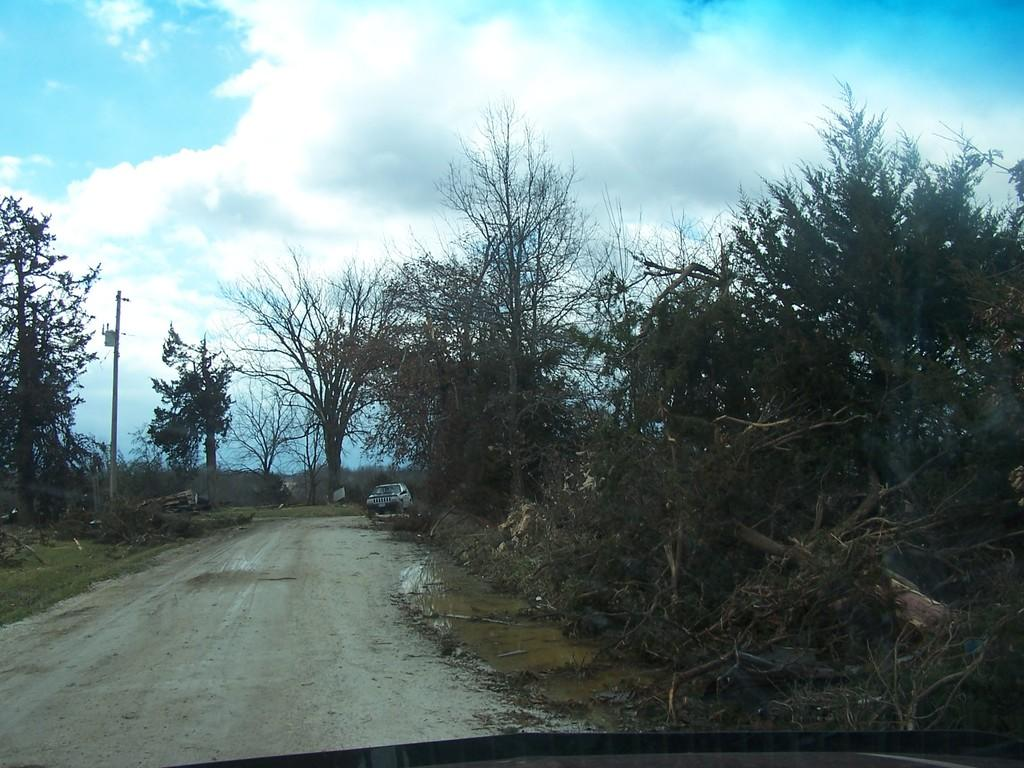What is the main subject in the image? There is a vehicle in the image. What type of natural elements can be seen in the image? There are trees and grass visible in the image. What man-made object is present in the image? There is a pole in the image. What can be seen in the background of the image? The sky with clouds is visible in the background of the image. How many ants are crawling on the vehicle in the image? There are no ants visible on the vehicle in the image. What direction is the vehicle facing in the image? The direction the vehicle is facing cannot be determined from the image alone, as there is no reference point to indicate its orientation. 